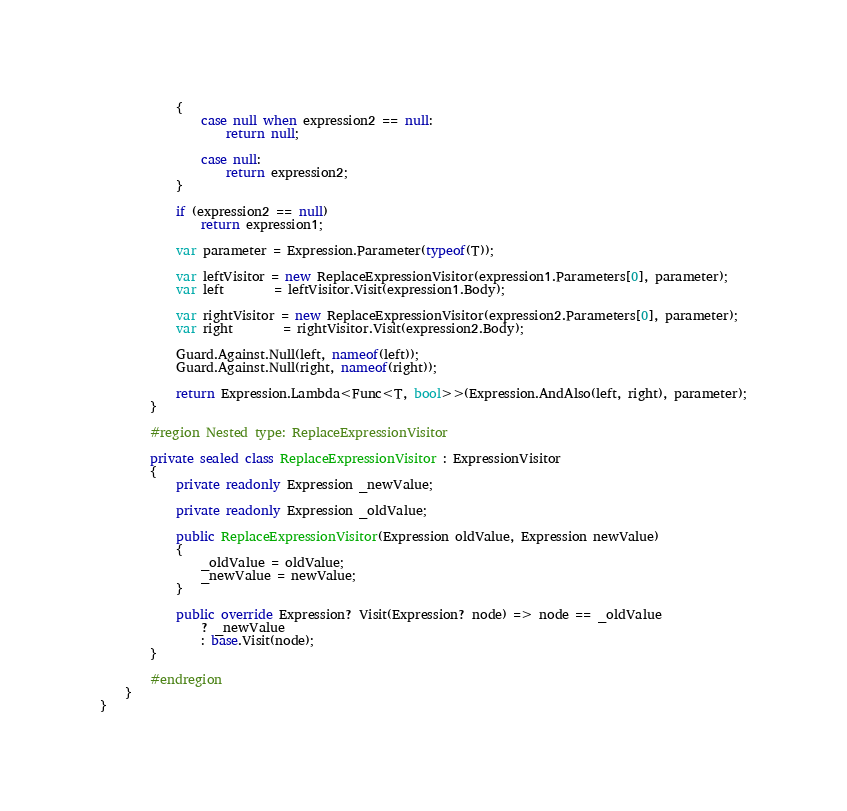Convert code to text. <code><loc_0><loc_0><loc_500><loc_500><_C#_>            {
                case null when expression2 == null:
                    return null;

                case null:
                    return expression2;
            }

            if (expression2 == null)
                return expression1;

            var parameter = Expression.Parameter(typeof(T));

            var leftVisitor = new ReplaceExpressionVisitor(expression1.Parameters[0], parameter);
            var left        = leftVisitor.Visit(expression1.Body);

            var rightVisitor = new ReplaceExpressionVisitor(expression2.Parameters[0], parameter);
            var right        = rightVisitor.Visit(expression2.Body);

            Guard.Against.Null(left, nameof(left));
            Guard.Against.Null(right, nameof(right));

            return Expression.Lambda<Func<T, bool>>(Expression.AndAlso(left, right), parameter);
        }

        #region Nested type: ReplaceExpressionVisitor

        private sealed class ReplaceExpressionVisitor : ExpressionVisitor
        {
            private readonly Expression _newValue;

            private readonly Expression _oldValue;

            public ReplaceExpressionVisitor(Expression oldValue, Expression newValue)
            {
                _oldValue = oldValue;
                _newValue = newValue;
            }

            public override Expression? Visit(Expression? node) => node == _oldValue
                ? _newValue
                : base.Visit(node);
        }

        #endregion
    }
}
</code> 